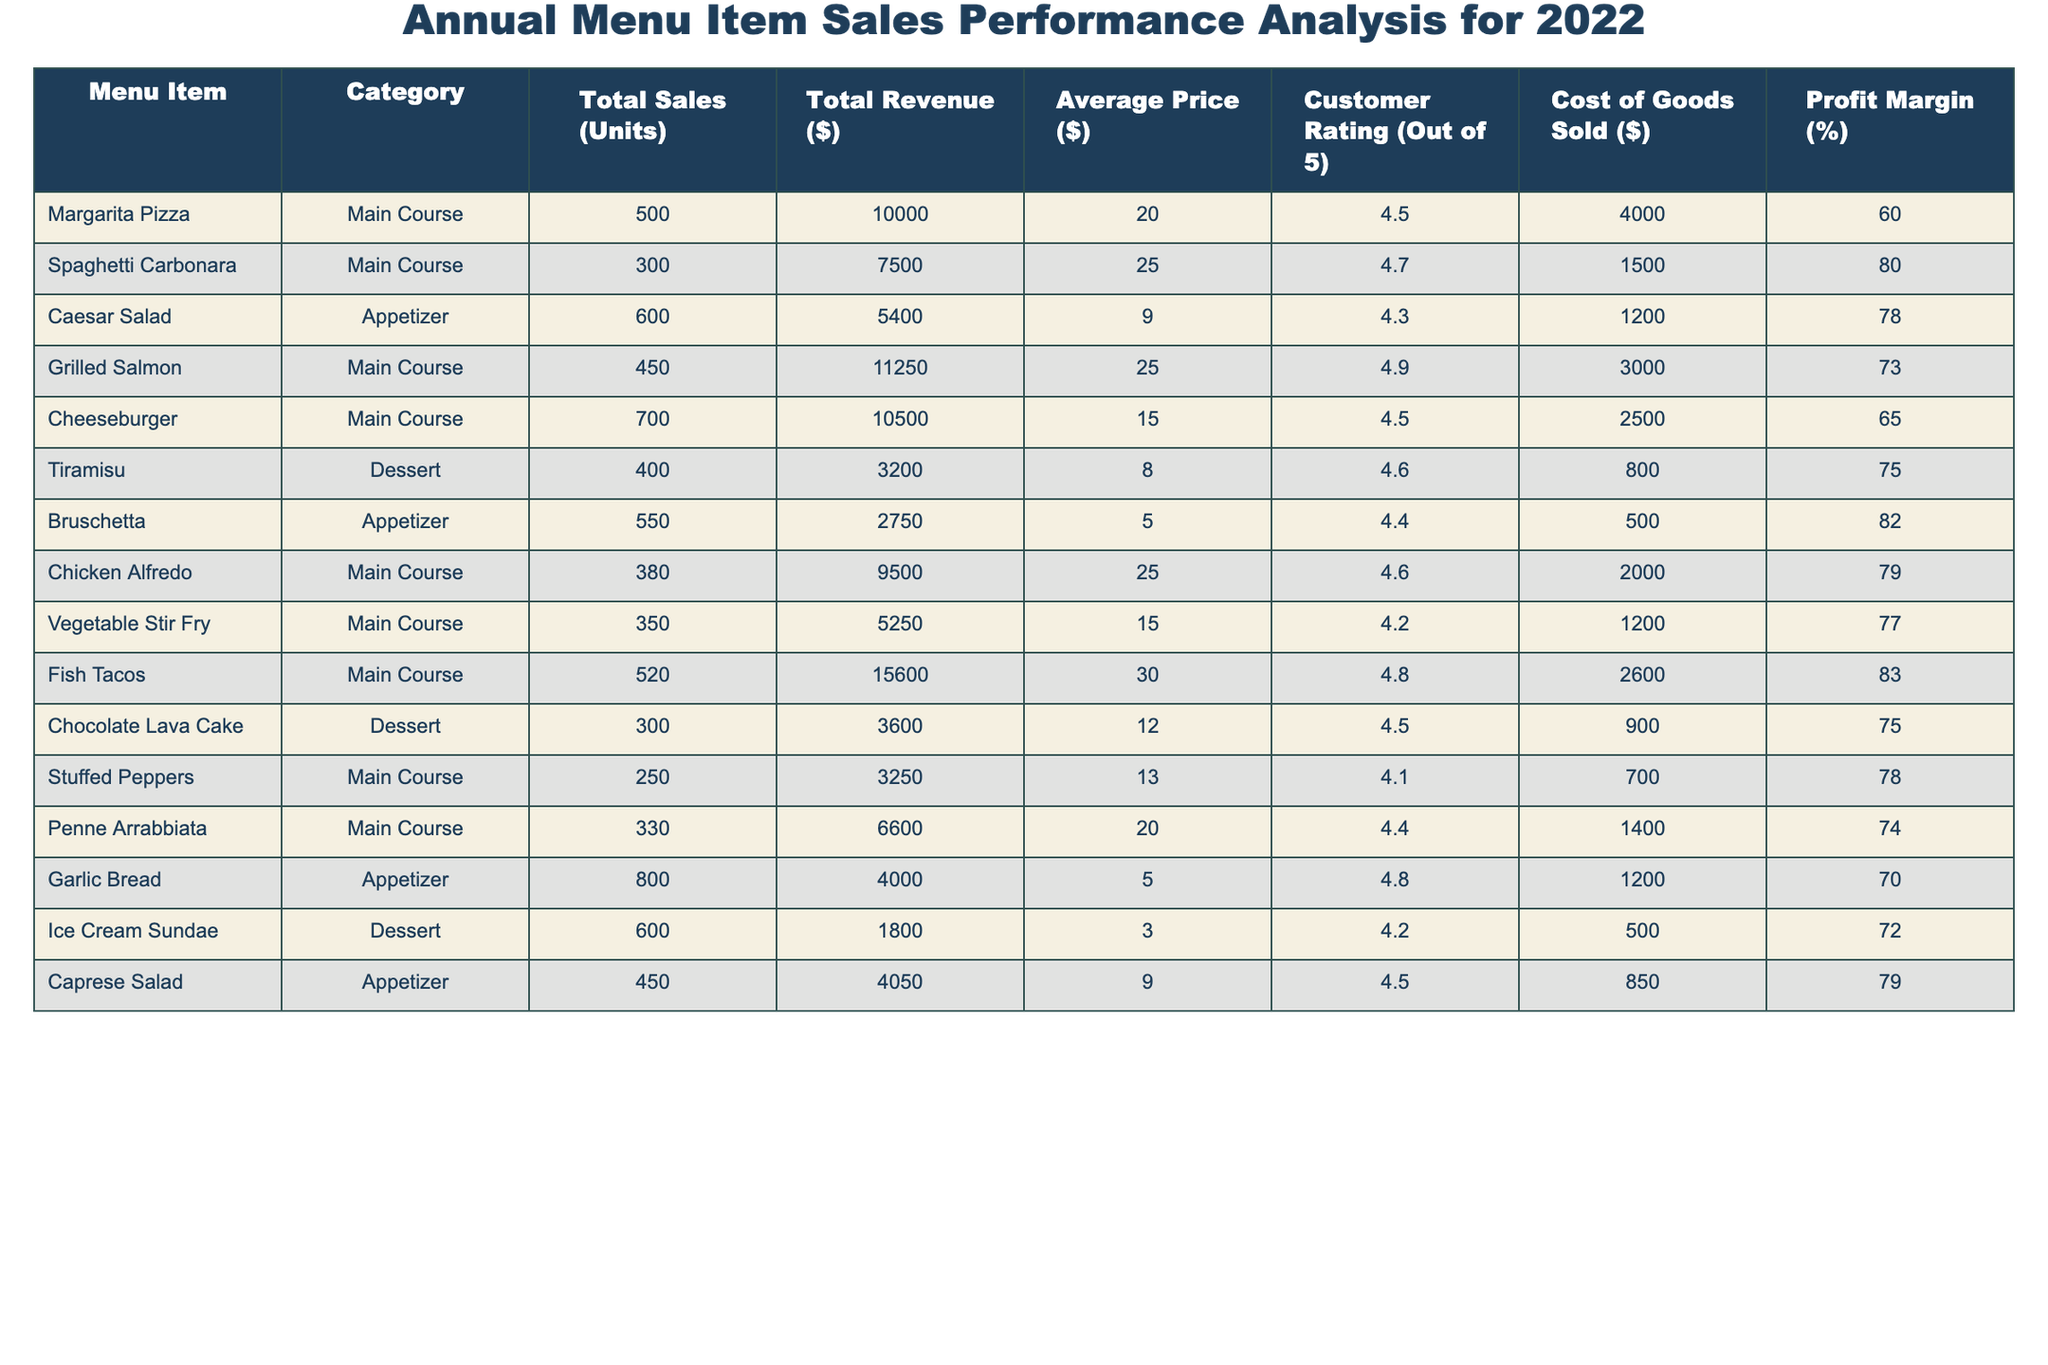What is the total revenue generated from the Cheeseburger? The Cheeseburger has a Total Revenue value listed in the table which is directly shown as $10,500.
Answer: $10,500 Which menu item has the highest profit margin? To find this, we look at the Profit Margin column and identify the maximum value. The Spaghetti Carbonara has the highest Profit Margin at 80%.
Answer: Spaghetti Carbonara What is the average customer rating of the desserts on the menu? The desserts are Tiramisu, Chocolate Lava Cake, and Ice Cream Sundae with customer ratings of 4.6, 4.5, and 4.2 respectively. The average rating is calculated as (4.6 + 4.5 + 4.2) / 3 = 4.46.
Answer: 4.46 Which category has the highest average price per item? We first calculate the average price for each category (Main Course, Appetizer, Dessert). The sums are: Main Course = (20 + 25 + 25 + 15 + 30 + 25 + 15 + 20) / 8 = 22.5, Appetizer = (9 + 5 + 9) / 3 = 7.67, Dessert = (8 + 12 + 3) / 3 = 7.67. The Main Course has the highest average price at $22.5.
Answer: Main Course Is the total sales of Grilled Salmon greater than the total sales of Spaghetti Carbonara? Comparing the Total Sales values, Grilled Salmon has 450 units sold while Spaghetti Carbonara has 300 units sold. Since 450 is greater than 300, the statement is true.
Answer: Yes What is the total number of units sold across all Appetizers? To find the total, we sum the units for the Appetizers: Caesar Salad (600) + Bruschetta (550) + Garlic Bread (800) + Caprese Salad (450) = 2900 units in total.
Answer: 2900 Which item generated the least revenue? Reviewing the Total Revenue column, the Ice Cream Sundae is at $1,800, which is the lowest among all menu items.
Answer: Ice Cream Sundae If we only consider the Main Course items, what is the average Profit Margin? The Profit Margins for Main Courses are 60%, 80%, 73%, 65%, 79%, 77%. The average calculation is (60 + 80 + 73 + 65 + 79 + 77) / 6 = 72.33%.
Answer: 72.33% How much total revenue did the appetizers generate compared to the total revenue from the desserts? Appetizers total revenue is (5400 + 2750 + 4000 + 4050) = $16,200 and desserts total revenue is (3200 + 3600 + 1800) = $8600. The Appetizers generated more revenue than Desserts.
Answer: Yes Which menu item represents the highest Total Sales? We examine the Total Sales column and find that the Cheeseburger has the highest figure at 700 units sold.
Answer: Cheeseburger 